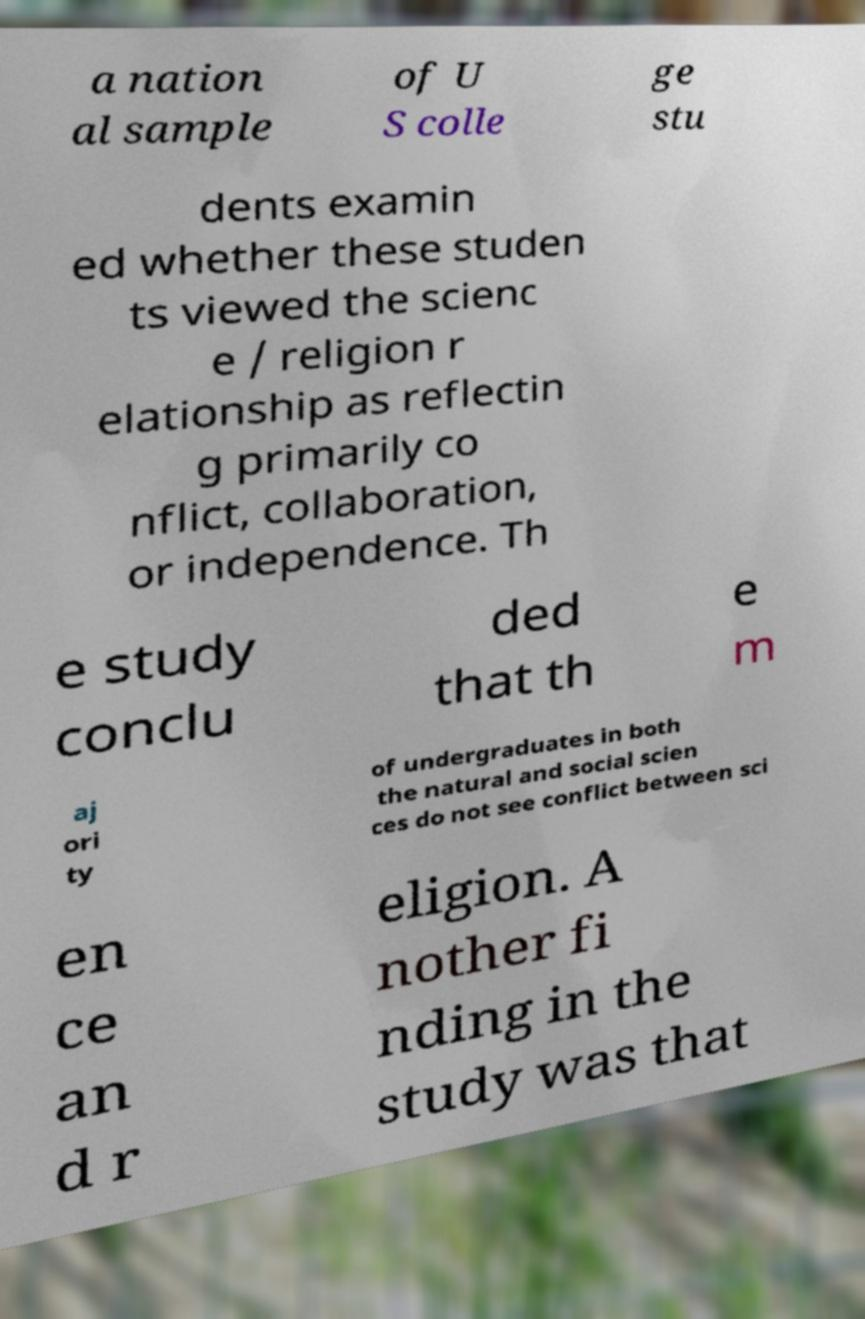Can you accurately transcribe the text from the provided image for me? a nation al sample of U S colle ge stu dents examin ed whether these studen ts viewed the scienc e / religion r elationship as reflectin g primarily co nflict, collaboration, or independence. Th e study conclu ded that th e m aj ori ty of undergraduates in both the natural and social scien ces do not see conflict between sci en ce an d r eligion. A nother fi nding in the study was that 